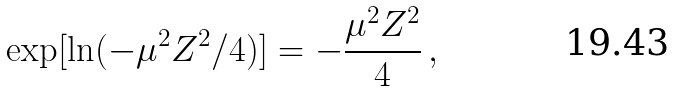<formula> <loc_0><loc_0><loc_500><loc_500>\exp [ \ln ( - \mu ^ { 2 } Z ^ { 2 } / 4 ) ] = - \frac { \mu ^ { 2 } Z ^ { 2 } } { 4 } \, ,</formula> 